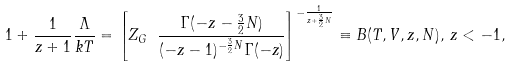<formula> <loc_0><loc_0><loc_500><loc_500>1 + \frac { 1 } { z + 1 } \frac { \Lambda } { k T } = \left [ Z _ { G } \ \frac { \Gamma ( - z - \frac { 3 } { 2 } N ) } { ( - z - 1 ) ^ { - \frac { 3 } { 2 } N } \Gamma ( - z ) } \right ] ^ { - \frac { 1 } { z + \frac { 3 } { 2 } N } } \equiv B ( T , V , z , N ) , \, z < - 1 ,</formula> 